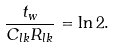<formula> <loc_0><loc_0><loc_500><loc_500>\frac { t _ { w } } { C _ { l k } R _ { l k } } = \ln 2 .</formula> 